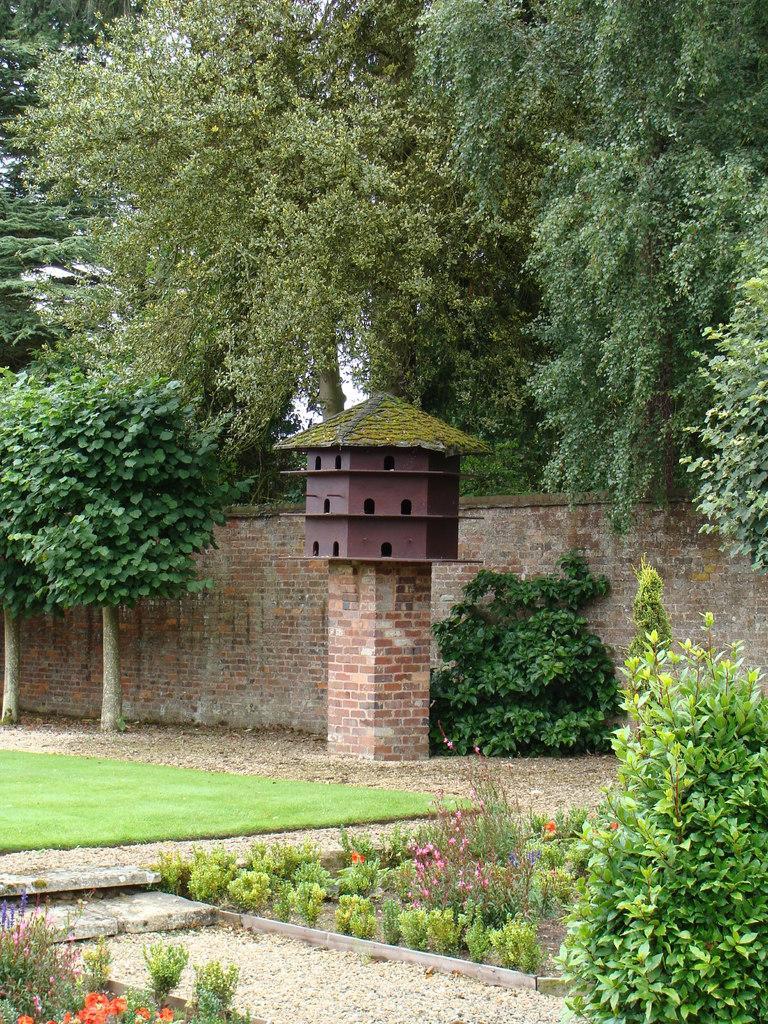In one or two sentences, can you explain what this image depicts? In this image there are many plants and grass on the ground. Also there are many trees. In the back there is a brick wall. Also there is a bird house on a stand with bricks. 